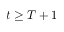<formula> <loc_0><loc_0><loc_500><loc_500>t \geq T + 1</formula> 